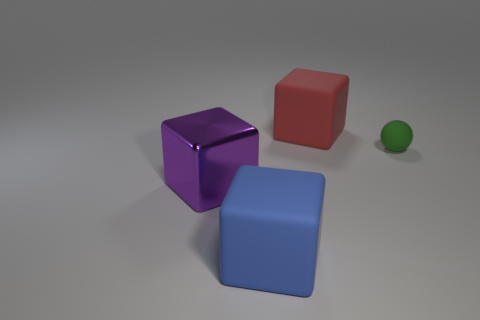Which of these objects is the smallest, and what color is it? The smallest object in the image is the sphere, and it has a green color. 